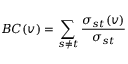Convert formula to latex. <formula><loc_0><loc_0><loc_500><loc_500>B C ( v ) = \sum _ { s \neq t } \frac { \sigma _ { s t } ( v ) } { \sigma _ { s t } }</formula> 